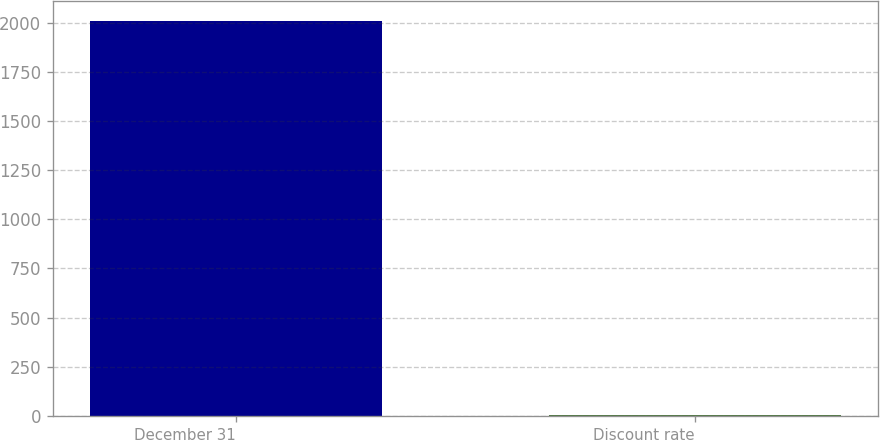Convert chart. <chart><loc_0><loc_0><loc_500><loc_500><bar_chart><fcel>December 31<fcel>Discount rate<nl><fcel>2007<fcel>5.89<nl></chart> 